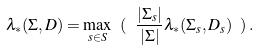<formula> <loc_0><loc_0><loc_500><loc_500>\lambda _ { * } ( \Sigma , D ) = \max _ { s \in S } \ ( \ \frac { | \Sigma _ { s } | } { | \Sigma | } \lambda _ { * } ( \Sigma _ { s } , D _ { s } ) \ ) \, .</formula> 